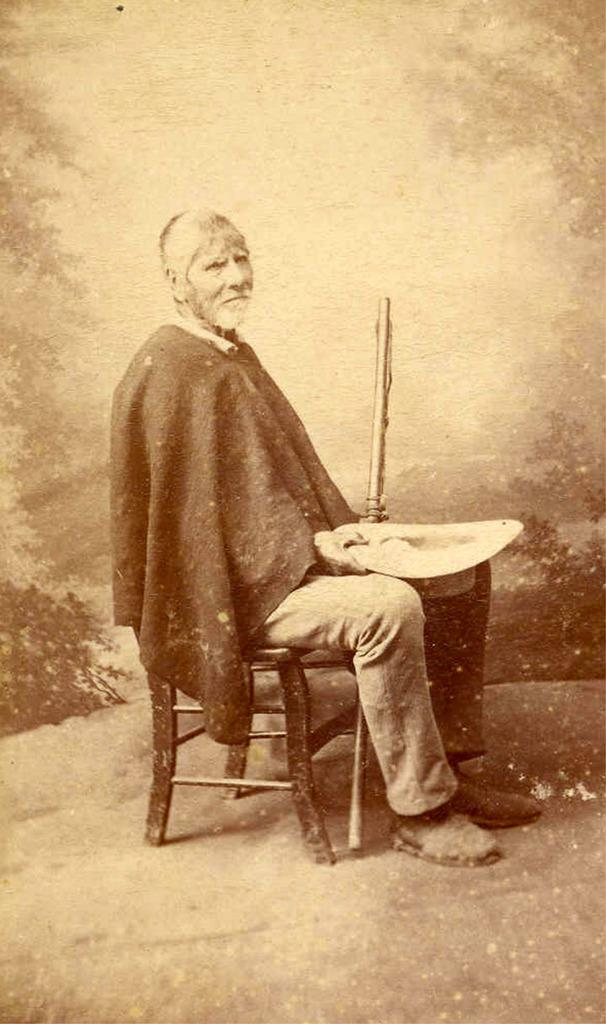What is the main subject of the image? There is a photo in the image. What can be seen in the photo? The photo contains a man. What is the man doing in the photo? The man is sitting on a chair and holding a stick. What type of table is the man using to spy on his competitors in the image? There is no table, spy, or competition present in the image. The man is simply sitting on a chair and holding a stick in a photo. 